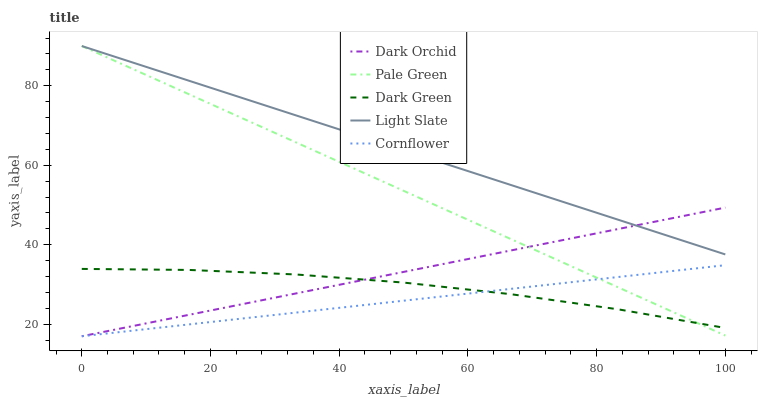Does Pale Green have the minimum area under the curve?
Answer yes or no. No. Does Pale Green have the maximum area under the curve?
Answer yes or no. No. Is Pale Green the smoothest?
Answer yes or no. No. Is Pale Green the roughest?
Answer yes or no. No. Does Pale Green have the lowest value?
Answer yes or no. No. Does Cornflower have the highest value?
Answer yes or no. No. Is Cornflower less than Light Slate?
Answer yes or no. Yes. Is Light Slate greater than Cornflower?
Answer yes or no. Yes. Does Cornflower intersect Light Slate?
Answer yes or no. No. 